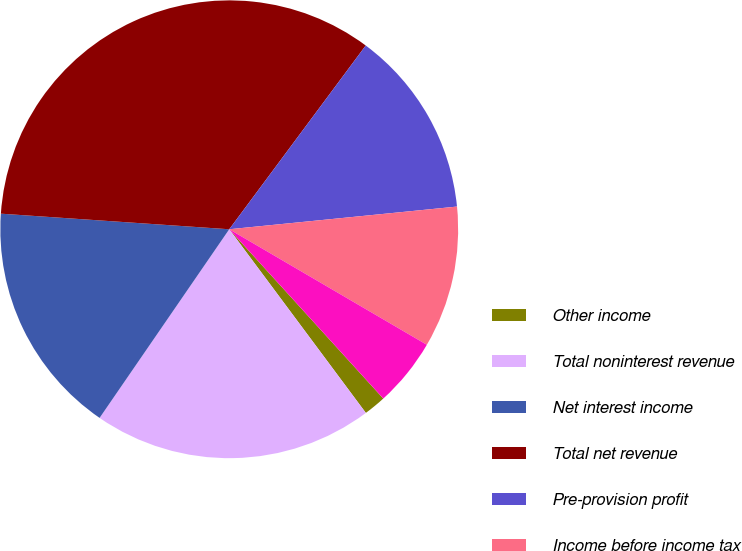Convert chart. <chart><loc_0><loc_0><loc_500><loc_500><pie_chart><fcel>Other income<fcel>Total noninterest revenue<fcel>Net interest income<fcel>Total net revenue<fcel>Pre-provision profit<fcel>Income before income tax<fcel>Income tax expense<nl><fcel>1.57%<fcel>19.76%<fcel>16.5%<fcel>34.08%<fcel>13.25%<fcel>10.0%<fcel>4.83%<nl></chart> 